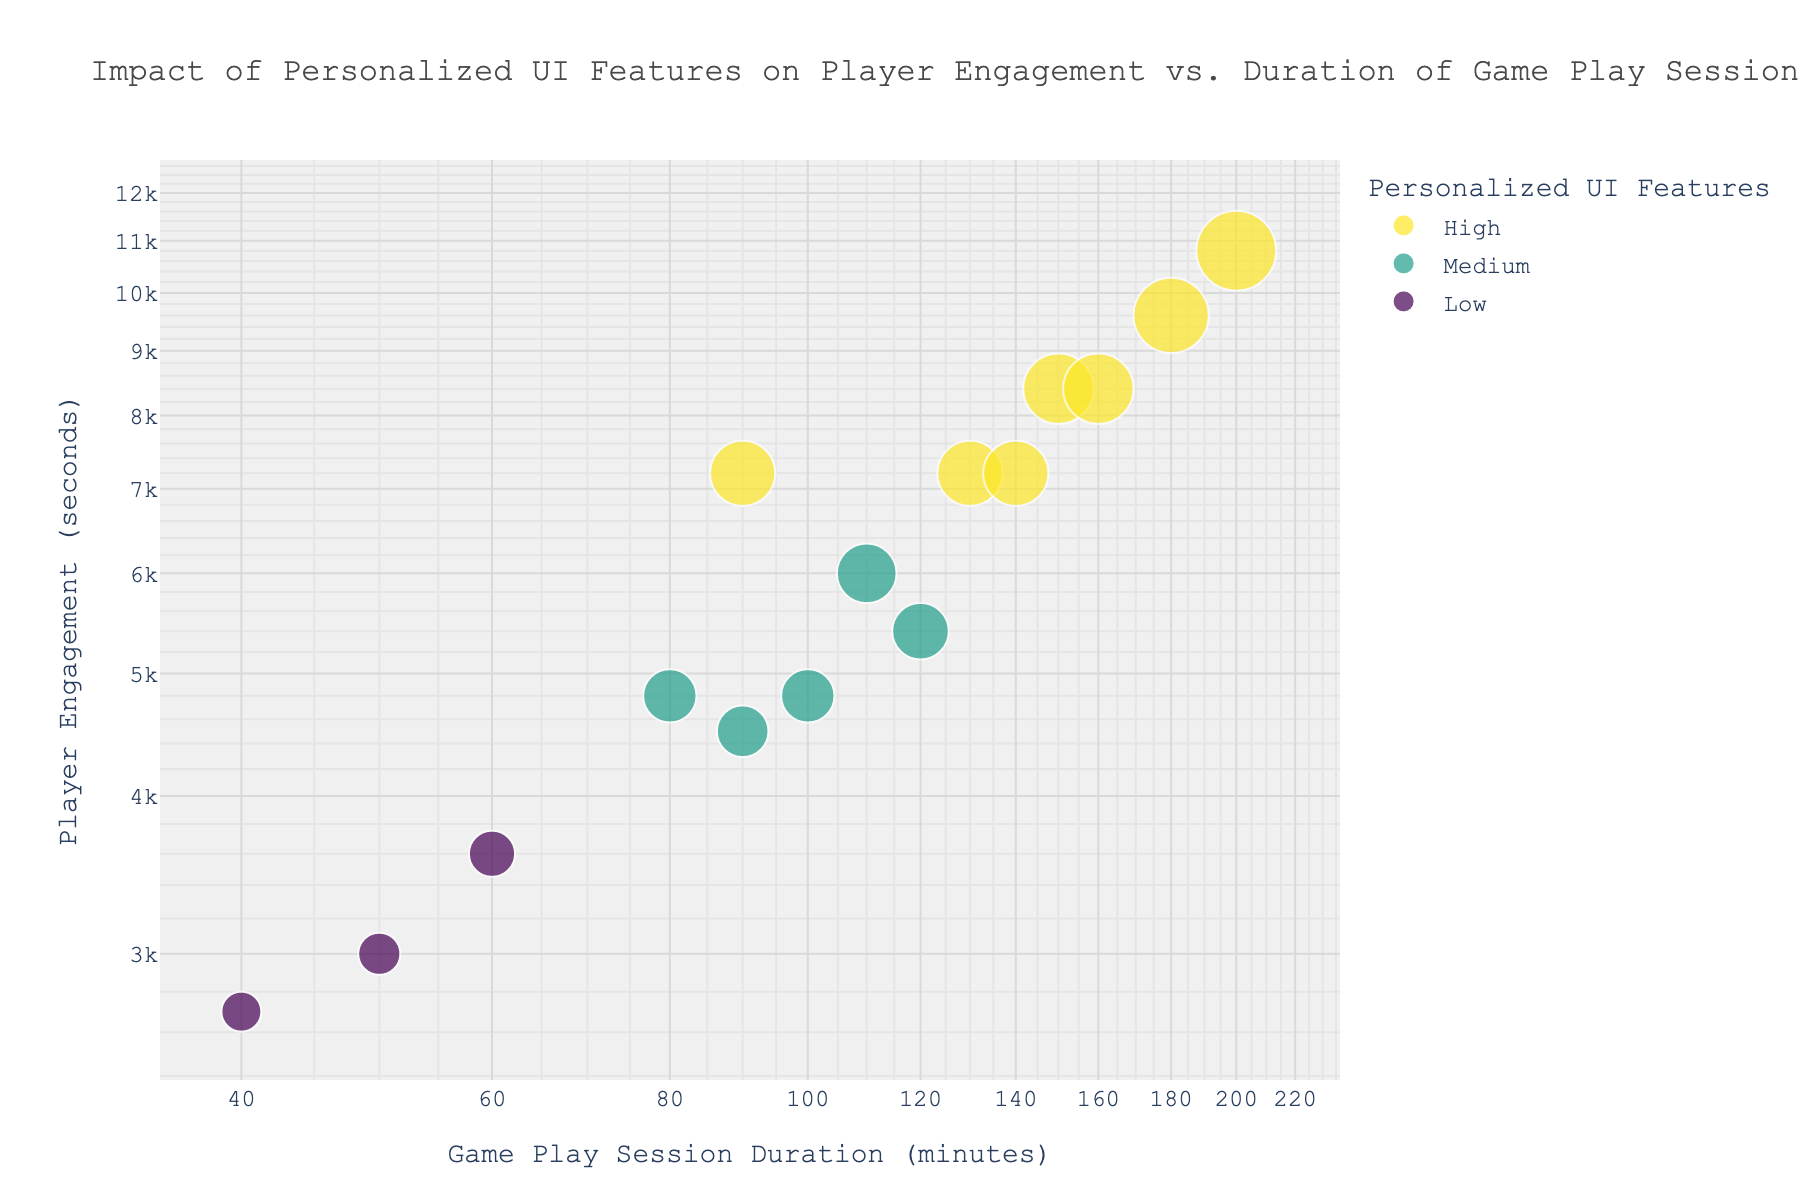What is the title of the figure? The title is displayed at the top of the figure in a larger font size than other text elements. It helps to understand the focus of the chart.
Answer: Impact of Personalized UI Features on Player Engagement vs. Duration of Game Play Sessions How many data points are shown in the figure? Count the number of individual dots visible on the scatter plot. Each dot represents one data point from the dataset.
Answer: 15 Which game has the highest duration of game play sessions? Identify the dot that appears furthest along the x-axis of the scatter plot. The hover text will confirm the game title when you focus on that dot.
Answer: Minecraft Which level of Personalized UI Features has the most data points? Look at the color coding in the legend and count how many dots are in each color category. "High" is one color, "Medium" is another, and "Low" is yet another.
Answer: High What most likely characterizes the games in the bottom-left corner of the plot? The bottom-left corner houses dots with low x and y values. Since the x-axis represents game play session duration and the y-axis represents player engagement, these games likely have short sessions and low engagement.
Answer: Short sessions and low engagement Is there a visible correlation between the duration of game play sessions and player engagement? Observe the overall trend of the dots. If the dots generally move upwards as they move to the right, there's a positive correlation; if they remain scattered without pattern, there’s no correlation.
Answer: Positive correlation Among the games with High personalized UI features, which one has the highest player engagement? Locate the dots in the color representing "High" level personalized UI features and find the one positioned highest along the y-axis.
Answer: Minecraft Compare the average session duration between games with Medium and Low Personalized UI Features. Add up the x-axis values for the "Medium" dots and divide by their count. Repeat for the "Low" dots, then compare the averages.
Answer: Medium: (120+100+110+80+90)/5 = 100, Low: (60+50+40)/3 ≈ 50, Medium has higher average session duration Are there any games with Low personalized UI features and high player engagement? Check if any dots with the color coding for "Low" Personalized UI Features are positioned high on the y-axis representing high player engagement.
Answer: No What can be inferred about the relationship between Personalized UI Features and Player Engagement? Analyze the distribution of dots for each level of personalized UI features concerning their position on the y-axis. If "High" dots are consistently higher than others, there is a relationship.
Answer: Higher Personalized UI Features generally correspond to higher Player Engagement 